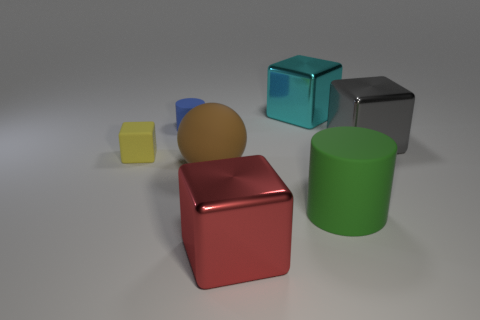Add 1 large matte cubes. How many objects exist? 8 Subtract all blocks. How many objects are left? 3 Add 3 red objects. How many red objects are left? 4 Add 3 cyan objects. How many cyan objects exist? 4 Subtract 0 yellow balls. How many objects are left? 7 Subtract all big objects. Subtract all purple objects. How many objects are left? 2 